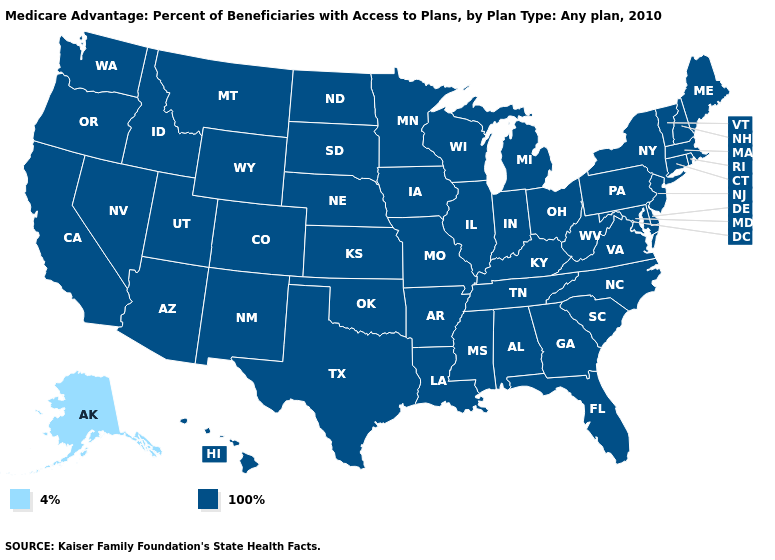Which states hav the highest value in the West?
Write a very short answer. Arizona, California, Colorado, Hawaii, Idaho, Montana, New Mexico, Nevada, Oregon, Utah, Washington, Wyoming. Does Texas have a lower value than Pennsylvania?
Keep it brief. No. What is the lowest value in the USA?
Give a very brief answer. 4%. What is the value of Texas?
Concise answer only. 100%. Name the states that have a value in the range 4%?
Write a very short answer. Alaska. What is the highest value in the USA?
Be succinct. 100%. What is the value of Alabama?
Give a very brief answer. 100%. Name the states that have a value in the range 100%?
Give a very brief answer. Alabama, Arkansas, Arizona, California, Colorado, Connecticut, Delaware, Florida, Georgia, Hawaii, Iowa, Idaho, Illinois, Indiana, Kansas, Kentucky, Louisiana, Massachusetts, Maryland, Maine, Michigan, Minnesota, Missouri, Mississippi, Montana, North Carolina, North Dakota, Nebraska, New Hampshire, New Jersey, New Mexico, Nevada, New York, Ohio, Oklahoma, Oregon, Pennsylvania, Rhode Island, South Carolina, South Dakota, Tennessee, Texas, Utah, Virginia, Vermont, Washington, Wisconsin, West Virginia, Wyoming. What is the lowest value in the MidWest?
Quick response, please. 100%. What is the lowest value in the USA?
Keep it brief. 4%. What is the value of Missouri?
Quick response, please. 100%. Does Alaska have the lowest value in the USA?
Quick response, please. Yes. 